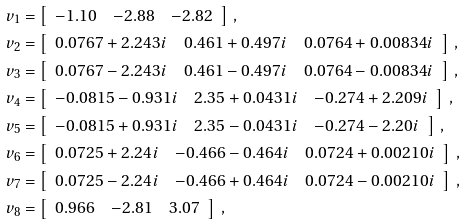Convert formula to latex. <formula><loc_0><loc_0><loc_500><loc_500>v _ { 1 } & = \left [ \begin{array} { c c c } - 1 . 1 0 & - 2 . 8 8 & - 2 . 8 2 \end{array} \right ] \, , \\ v _ { 2 } & = \left [ \begin{array} { c c c } 0 . 0 7 6 7 + 2 . 2 4 3 i & 0 . 4 6 1 + 0 . 4 9 7 i & 0 . 0 7 6 4 + 0 . 0 0 8 3 4 i \end{array} \right ] \, , \\ v _ { 3 } & = \left [ \begin{array} { c c c } 0 . 0 7 6 7 - 2 . 2 4 3 i & 0 . 4 6 1 - 0 . 4 9 7 i & 0 . 0 7 6 4 - 0 . 0 0 8 3 4 i \end{array} \right ] \, , \\ v _ { 4 } & = \left [ \begin{array} { c c c } - 0 . 0 8 1 5 - 0 . 9 3 1 i & 2 . 3 5 + 0 . 0 4 3 1 i & - 0 . 2 7 4 + 2 . 2 0 9 i \end{array} \right ] \, , \\ v _ { 5 } & = \left [ \begin{array} { c c c } - 0 . 0 8 1 5 + 0 . 9 3 1 i & 2 . 3 5 - 0 . 0 4 3 1 i & - 0 . 2 7 4 - 2 . 2 0 i \end{array} \right ] \, , \\ v _ { 6 } & = \left [ \begin{array} { c c c } 0 . 0 7 2 5 + 2 . 2 4 i & - 0 . 4 6 6 - 0 . 4 6 4 i & 0 . 0 7 2 4 + 0 . 0 0 2 1 0 i \end{array} \right ] \, , \\ v _ { 7 } & = \left [ \begin{array} { c c c } 0 . 0 7 2 5 - 2 . 2 4 i & - 0 . 4 6 6 + 0 . 4 6 4 i & 0 . 0 7 2 4 - 0 . 0 0 2 1 0 i \end{array} \right ] \, , \\ v _ { 8 } & = \left [ \begin{array} { c c c } 0 . 9 6 6 & - 2 . 8 1 & 3 . 0 7 \end{array} \right ] \, ,</formula> 